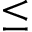<formula> <loc_0><loc_0><loc_500><loc_500>\leq</formula> 